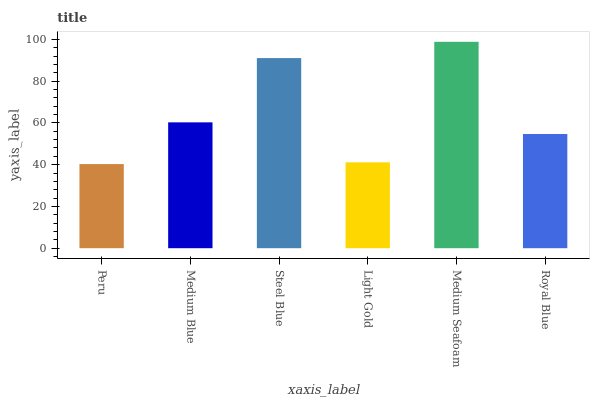Is Peru the minimum?
Answer yes or no. Yes. Is Medium Seafoam the maximum?
Answer yes or no. Yes. Is Medium Blue the minimum?
Answer yes or no. No. Is Medium Blue the maximum?
Answer yes or no. No. Is Medium Blue greater than Peru?
Answer yes or no. Yes. Is Peru less than Medium Blue?
Answer yes or no. Yes. Is Peru greater than Medium Blue?
Answer yes or no. No. Is Medium Blue less than Peru?
Answer yes or no. No. Is Medium Blue the high median?
Answer yes or no. Yes. Is Royal Blue the low median?
Answer yes or no. Yes. Is Light Gold the high median?
Answer yes or no. No. Is Peru the low median?
Answer yes or no. No. 